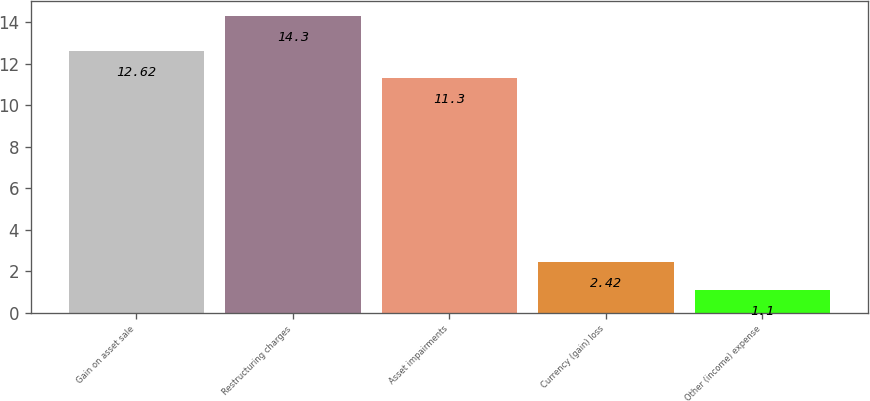Convert chart to OTSL. <chart><loc_0><loc_0><loc_500><loc_500><bar_chart><fcel>Gain on asset sale<fcel>Restructuring charges<fcel>Asset impairments<fcel>Currency (gain) loss<fcel>Other (income) expense<nl><fcel>12.62<fcel>14.3<fcel>11.3<fcel>2.42<fcel>1.1<nl></chart> 